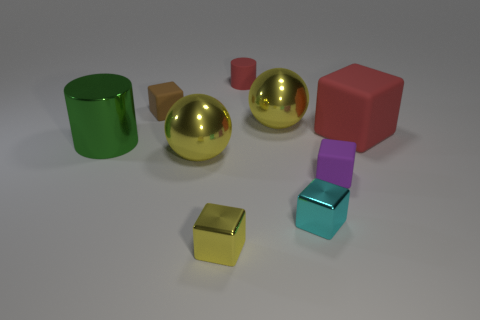There is a rubber thing that is the same color as the big rubber block; what is its size?
Keep it short and to the point. Small. Do the green cylinder and the brown matte thing have the same size?
Provide a succinct answer. No. What shape is the large yellow shiny thing that is to the left of the large yellow shiny sphere that is behind the large sphere on the left side of the small red matte object?
Keep it short and to the point. Sphere. There is another rubber thing that is the same shape as the large green thing; what is its color?
Give a very brief answer. Red. There is a block that is to the right of the yellow metal cube and in front of the purple object; how big is it?
Your answer should be very brief. Small. How many rubber cubes are to the left of the cylinder in front of the red rubber object to the right of the purple rubber block?
Offer a very short reply. 0. How many tiny things are shiny cylinders or shiny things?
Offer a very short reply. 2. Is the big yellow thing in front of the large green cylinder made of the same material as the cyan cube?
Offer a terse response. Yes. What material is the cylinder on the right side of the small thing on the left side of the large thing that is in front of the large green cylinder?
Provide a short and direct response. Rubber. How many metallic things are either tiny purple blocks or tiny cyan cubes?
Keep it short and to the point. 1. 